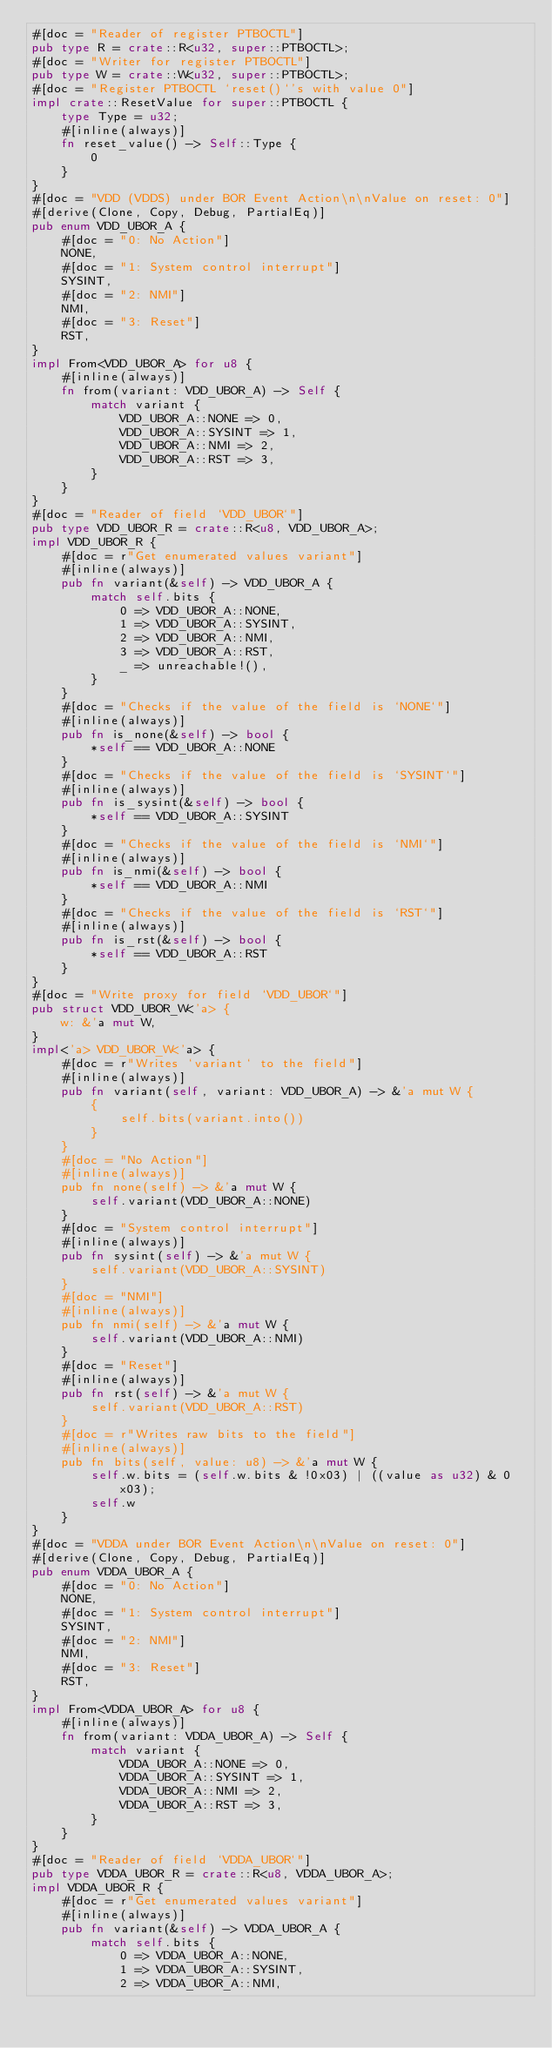<code> <loc_0><loc_0><loc_500><loc_500><_Rust_>#[doc = "Reader of register PTBOCTL"]
pub type R = crate::R<u32, super::PTBOCTL>;
#[doc = "Writer for register PTBOCTL"]
pub type W = crate::W<u32, super::PTBOCTL>;
#[doc = "Register PTBOCTL `reset()`'s with value 0"]
impl crate::ResetValue for super::PTBOCTL {
    type Type = u32;
    #[inline(always)]
    fn reset_value() -> Self::Type {
        0
    }
}
#[doc = "VDD (VDDS) under BOR Event Action\n\nValue on reset: 0"]
#[derive(Clone, Copy, Debug, PartialEq)]
pub enum VDD_UBOR_A {
    #[doc = "0: No Action"]
    NONE,
    #[doc = "1: System control interrupt"]
    SYSINT,
    #[doc = "2: NMI"]
    NMI,
    #[doc = "3: Reset"]
    RST,
}
impl From<VDD_UBOR_A> for u8 {
    #[inline(always)]
    fn from(variant: VDD_UBOR_A) -> Self {
        match variant {
            VDD_UBOR_A::NONE => 0,
            VDD_UBOR_A::SYSINT => 1,
            VDD_UBOR_A::NMI => 2,
            VDD_UBOR_A::RST => 3,
        }
    }
}
#[doc = "Reader of field `VDD_UBOR`"]
pub type VDD_UBOR_R = crate::R<u8, VDD_UBOR_A>;
impl VDD_UBOR_R {
    #[doc = r"Get enumerated values variant"]
    #[inline(always)]
    pub fn variant(&self) -> VDD_UBOR_A {
        match self.bits {
            0 => VDD_UBOR_A::NONE,
            1 => VDD_UBOR_A::SYSINT,
            2 => VDD_UBOR_A::NMI,
            3 => VDD_UBOR_A::RST,
            _ => unreachable!(),
        }
    }
    #[doc = "Checks if the value of the field is `NONE`"]
    #[inline(always)]
    pub fn is_none(&self) -> bool {
        *self == VDD_UBOR_A::NONE
    }
    #[doc = "Checks if the value of the field is `SYSINT`"]
    #[inline(always)]
    pub fn is_sysint(&self) -> bool {
        *self == VDD_UBOR_A::SYSINT
    }
    #[doc = "Checks if the value of the field is `NMI`"]
    #[inline(always)]
    pub fn is_nmi(&self) -> bool {
        *self == VDD_UBOR_A::NMI
    }
    #[doc = "Checks if the value of the field is `RST`"]
    #[inline(always)]
    pub fn is_rst(&self) -> bool {
        *self == VDD_UBOR_A::RST
    }
}
#[doc = "Write proxy for field `VDD_UBOR`"]
pub struct VDD_UBOR_W<'a> {
    w: &'a mut W,
}
impl<'a> VDD_UBOR_W<'a> {
    #[doc = r"Writes `variant` to the field"]
    #[inline(always)]
    pub fn variant(self, variant: VDD_UBOR_A) -> &'a mut W {
        {
            self.bits(variant.into())
        }
    }
    #[doc = "No Action"]
    #[inline(always)]
    pub fn none(self) -> &'a mut W {
        self.variant(VDD_UBOR_A::NONE)
    }
    #[doc = "System control interrupt"]
    #[inline(always)]
    pub fn sysint(self) -> &'a mut W {
        self.variant(VDD_UBOR_A::SYSINT)
    }
    #[doc = "NMI"]
    #[inline(always)]
    pub fn nmi(self) -> &'a mut W {
        self.variant(VDD_UBOR_A::NMI)
    }
    #[doc = "Reset"]
    #[inline(always)]
    pub fn rst(self) -> &'a mut W {
        self.variant(VDD_UBOR_A::RST)
    }
    #[doc = r"Writes raw bits to the field"]
    #[inline(always)]
    pub fn bits(self, value: u8) -> &'a mut W {
        self.w.bits = (self.w.bits & !0x03) | ((value as u32) & 0x03);
        self.w
    }
}
#[doc = "VDDA under BOR Event Action\n\nValue on reset: 0"]
#[derive(Clone, Copy, Debug, PartialEq)]
pub enum VDDA_UBOR_A {
    #[doc = "0: No Action"]
    NONE,
    #[doc = "1: System control interrupt"]
    SYSINT,
    #[doc = "2: NMI"]
    NMI,
    #[doc = "3: Reset"]
    RST,
}
impl From<VDDA_UBOR_A> for u8 {
    #[inline(always)]
    fn from(variant: VDDA_UBOR_A) -> Self {
        match variant {
            VDDA_UBOR_A::NONE => 0,
            VDDA_UBOR_A::SYSINT => 1,
            VDDA_UBOR_A::NMI => 2,
            VDDA_UBOR_A::RST => 3,
        }
    }
}
#[doc = "Reader of field `VDDA_UBOR`"]
pub type VDDA_UBOR_R = crate::R<u8, VDDA_UBOR_A>;
impl VDDA_UBOR_R {
    #[doc = r"Get enumerated values variant"]
    #[inline(always)]
    pub fn variant(&self) -> VDDA_UBOR_A {
        match self.bits {
            0 => VDDA_UBOR_A::NONE,
            1 => VDDA_UBOR_A::SYSINT,
            2 => VDDA_UBOR_A::NMI,</code> 